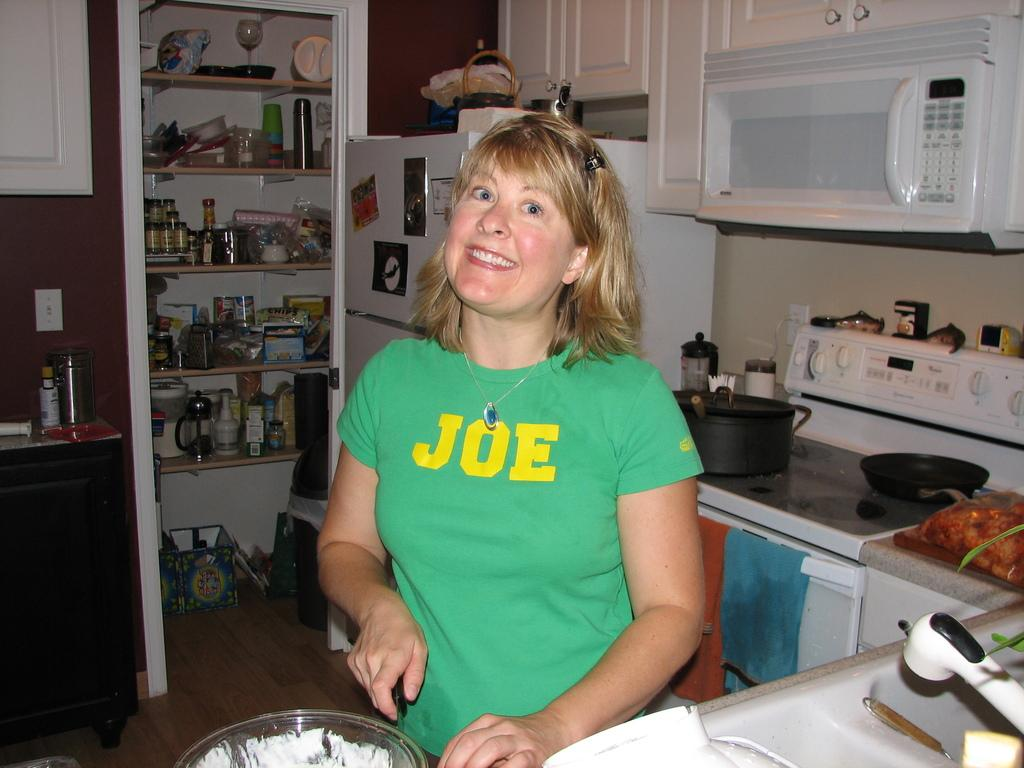<image>
Relay a brief, clear account of the picture shown. a woman smiling with a JOE T-shirt on in her kitchen. 